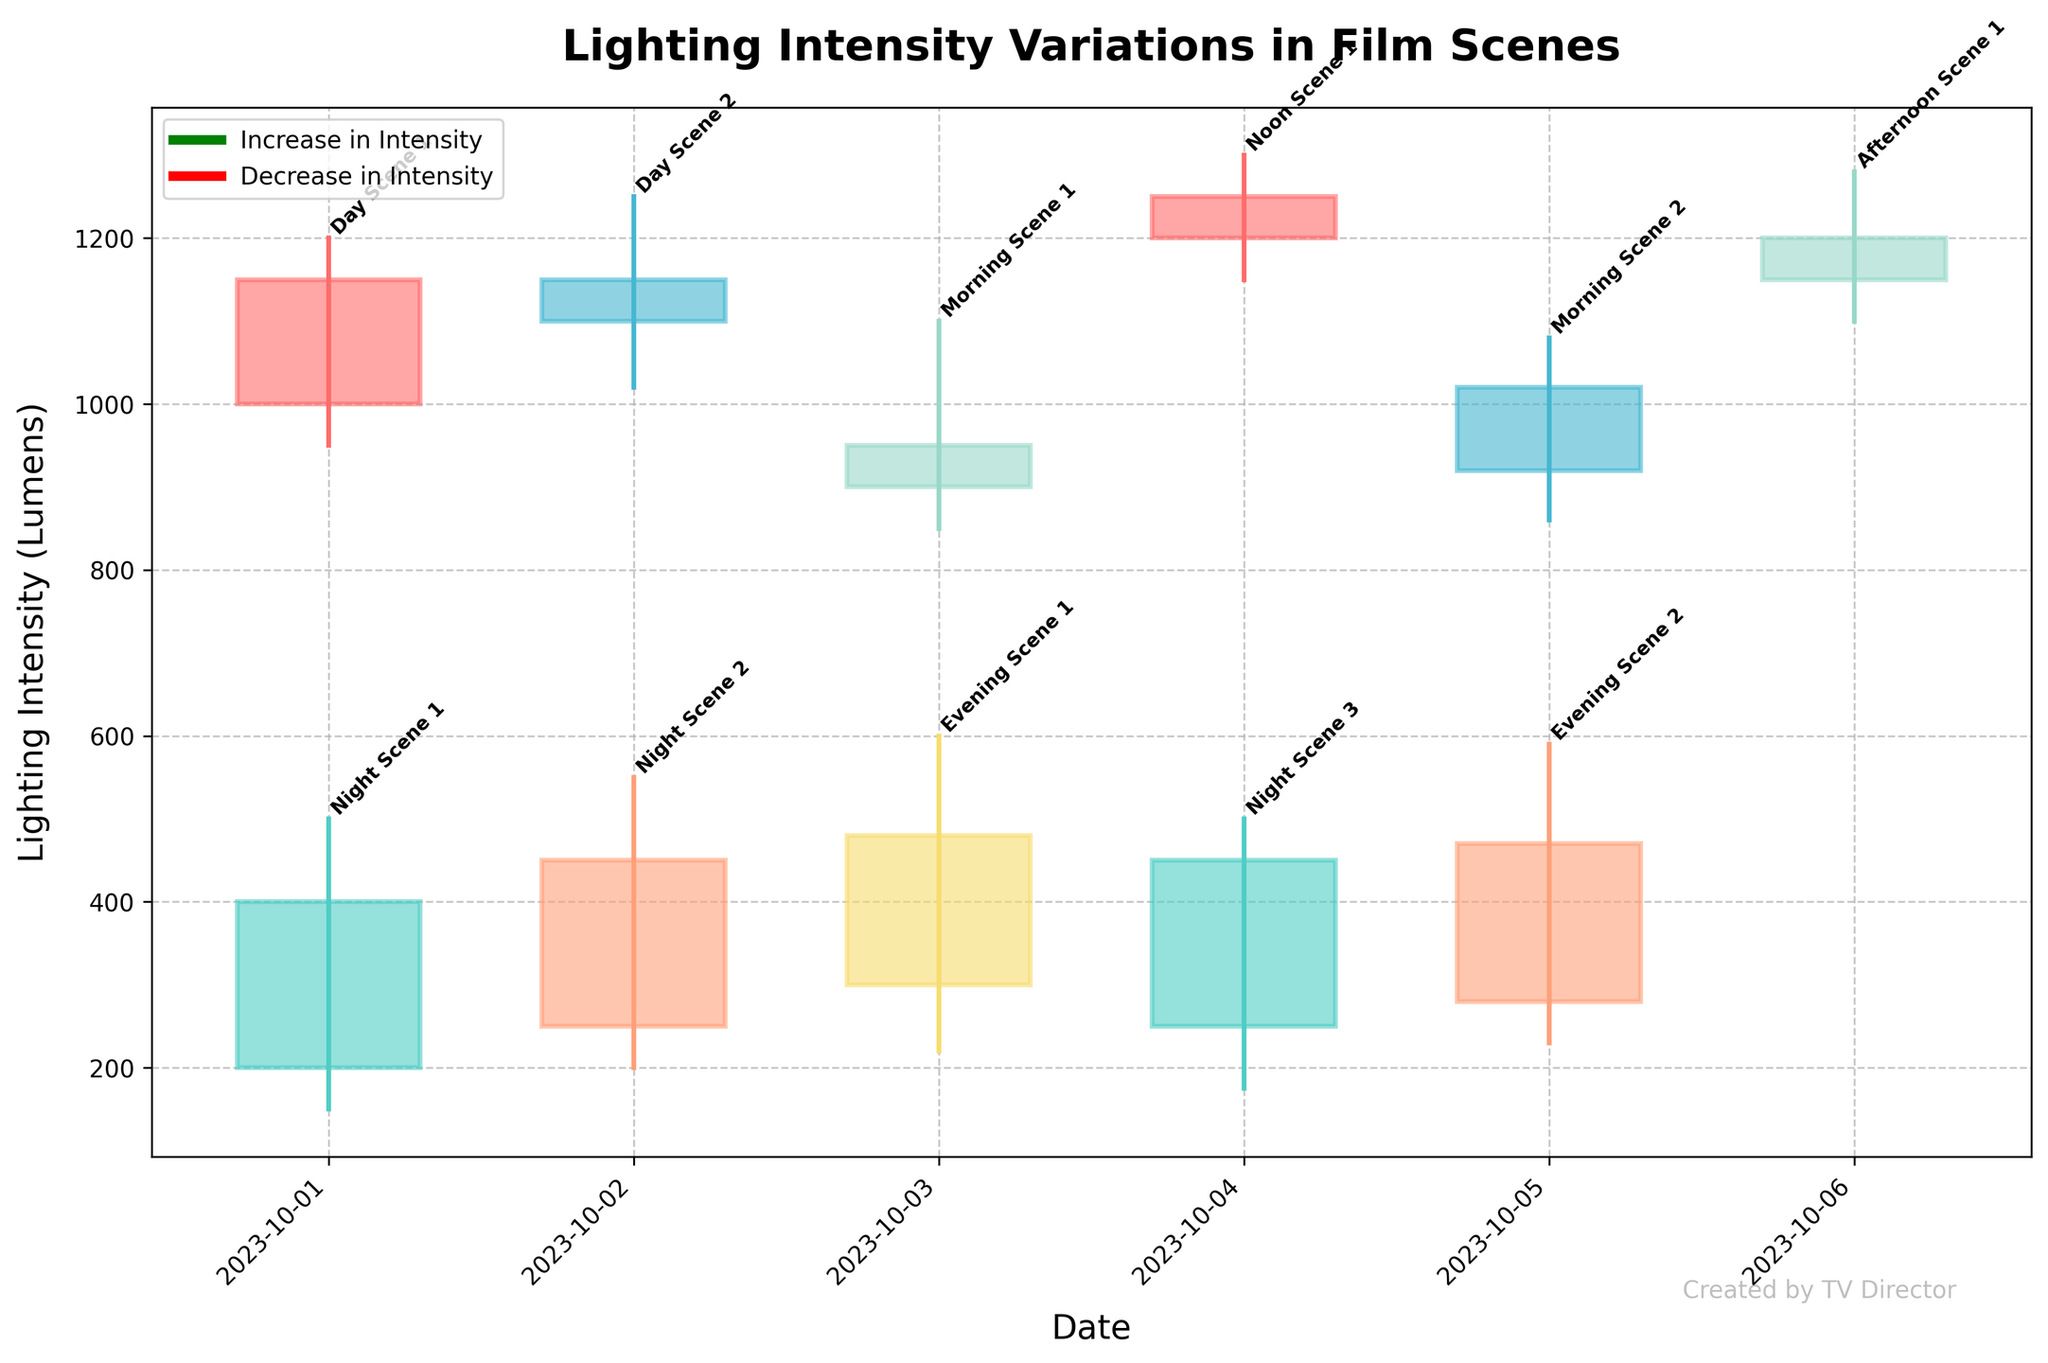What is the title of the candlestick plot? The plot title is usually placed at the top center of the plot. This particular plot's title helps to understand the general theme and the subject matter of the visualization.
Answer: Lighting Intensity Variations in Film Scenes How many scenes are plotted on the candlestick chart? By counting the number of labeled candlesticks (each representing a session) on the x-axis, we can determine the number of scenes. Each candlestick corresponds to one scene's lighting intensity data.
Answer: 10 Which session had the lowest lighting intensity? To determine the session with the lowest intensity, look at the candlestick with both the lowest 'low' value and the lowest 'close' value on the plot. Identify the corresponding label.
Answer: Night Scene 1 On which date did the Day Scene 1 session occur? The date for each session is typically labeled on the x-axis beneath each candlestick. Identify the candlestick labeled with "Day Scene 1" and note the date below it.
Answer: 2023-10-01 Which scene had the highest peak lighting intensity? To find the highest peak intensity, locate the candlestick with the highest 'high' value on the y-axis. Identify the corresponding session label.
Answer: Noon Scene 1 Compare the lighting intensity range between Day Scene 1 and Night Scene 1. Which one had a broader range? Calculate the range for both sessions by finding the difference between their 'high' and 'low' values. Compare the ranges: Day Scene 1 (1200-950) and Night Scene 1 (500-150)
Answer: Day Scene 1 On 2023-10-02, how did the lighting intensities change from Day Scene 2 to Night Scene 2? Examine the candlesticks for both sessions on 2023-10-02. Compare their opening and closing values to understand the direction of change: Day Scene 2 (1150-1100) and Night Scene 2 (450-250).
Answer: Increased in Day, Increased in Night Which scene showed the highest increase in lighting intensity from open to close? To find the session with the highest increase, calculate the difference (close - open) for each session and identify the session with the largest positive difference.
Answer: Night Scene 2 What is the range of lighting intensity for Afternoon Scene 1? The range can be found by subtracting the 'low' value from the 'high' value of the candlestick representing Afternoon Scene 1: (1280 - 1100).
Answer: 180 How does the color scheme help differentiate between increases and decreases in intensity? Observe the visual differences in color for candlesticks where the closing value is higher than the opening (e.g., more filled/bold colors) versus when it's lower (e.g., more transparent). This helps quickly identify sessions with increased or decreased intensities.
Answer: Color differentiation 